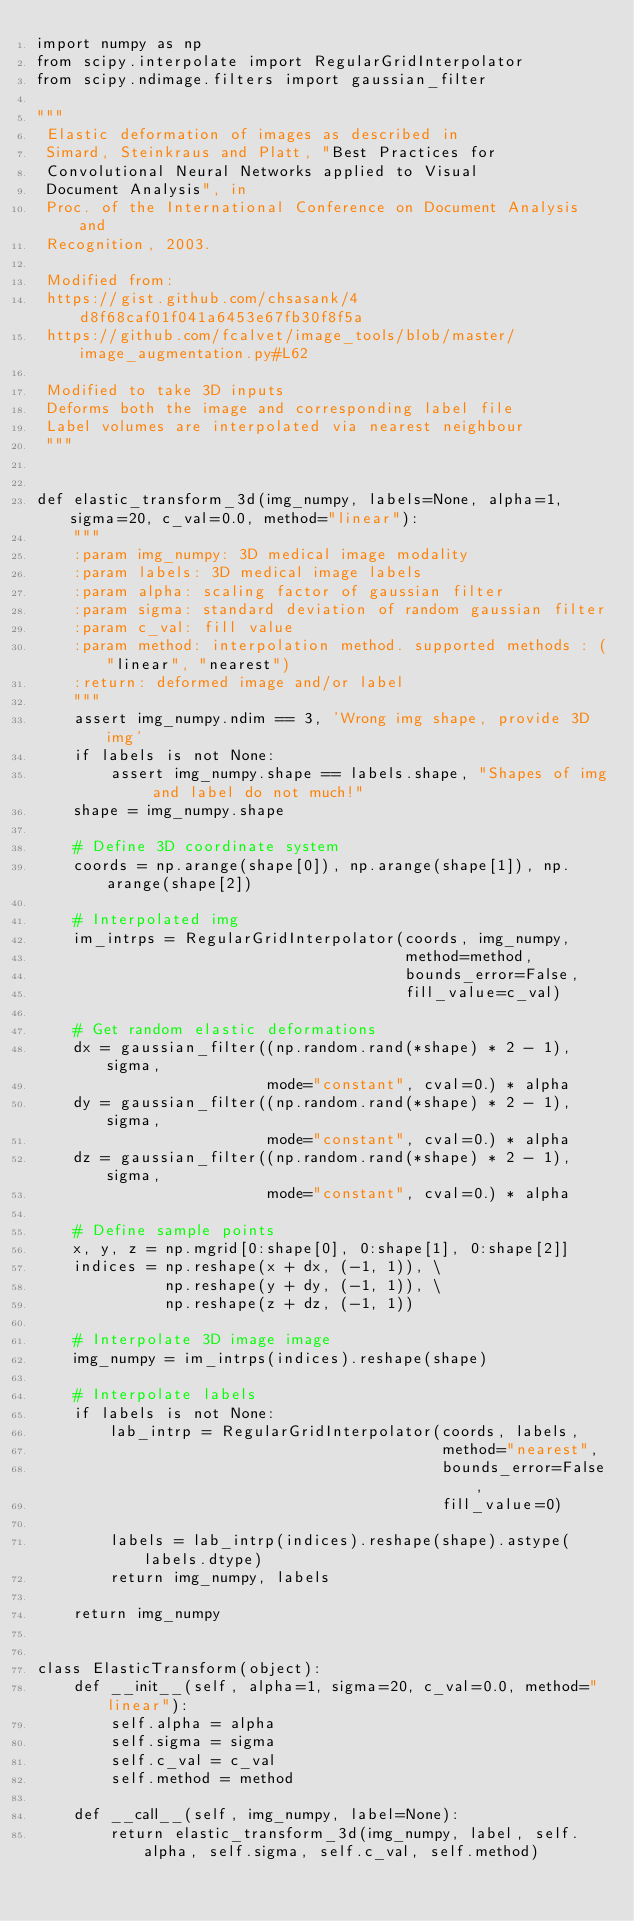Convert code to text. <code><loc_0><loc_0><loc_500><loc_500><_Python_>import numpy as np
from scipy.interpolate import RegularGridInterpolator
from scipy.ndimage.filters import gaussian_filter

"""
 Elastic deformation of images as described in
 Simard, Steinkraus and Platt, "Best Practices for
 Convolutional Neural Networks applied to Visual
 Document Analysis", in
 Proc. of the International Conference on Document Analysis and
 Recognition, 2003.

 Modified from:
 https://gist.github.com/chsasank/4d8f68caf01f041a6453e67fb30f8f5a
 https://github.com/fcalvet/image_tools/blob/master/image_augmentation.py#L62

 Modified to take 3D inputs
 Deforms both the image and corresponding label file
 Label volumes are interpolated via nearest neighbour 
 """


def elastic_transform_3d(img_numpy, labels=None, alpha=1, sigma=20, c_val=0.0, method="linear"):
    """
    :param img_numpy: 3D medical image modality
    :param labels: 3D medical image labels
    :param alpha: scaling factor of gaussian filter
    :param sigma: standard deviation of random gaussian filter
    :param c_val: fill value
    :param method: interpolation method. supported methods : ("linear", "nearest")
    :return: deformed image and/or label
    """
    assert img_numpy.ndim == 3, 'Wrong img shape, provide 3D img'
    if labels is not None:
        assert img_numpy.shape == labels.shape, "Shapes of img and label do not much!"
    shape = img_numpy.shape

    # Define 3D coordinate system
    coords = np.arange(shape[0]), np.arange(shape[1]), np.arange(shape[2])

    # Interpolated img
    im_intrps = RegularGridInterpolator(coords, img_numpy,
                                        method=method,
                                        bounds_error=False,
                                        fill_value=c_val)

    # Get random elastic deformations
    dx = gaussian_filter((np.random.rand(*shape) * 2 - 1), sigma,
                         mode="constant", cval=0.) * alpha
    dy = gaussian_filter((np.random.rand(*shape) * 2 - 1), sigma,
                         mode="constant", cval=0.) * alpha
    dz = gaussian_filter((np.random.rand(*shape) * 2 - 1), sigma,
                         mode="constant", cval=0.) * alpha

    # Define sample points
    x, y, z = np.mgrid[0:shape[0], 0:shape[1], 0:shape[2]]
    indices = np.reshape(x + dx, (-1, 1)), \
              np.reshape(y + dy, (-1, 1)), \
              np.reshape(z + dz, (-1, 1))

    # Interpolate 3D image image
    img_numpy = im_intrps(indices).reshape(shape)

    # Interpolate labels
    if labels is not None:
        lab_intrp = RegularGridInterpolator(coords, labels,
                                            method="nearest",
                                            bounds_error=False,
                                            fill_value=0)

        labels = lab_intrp(indices).reshape(shape).astype(labels.dtype)
        return img_numpy, labels

    return img_numpy


class ElasticTransform(object):
    def __init__(self, alpha=1, sigma=20, c_val=0.0, method="linear"):
        self.alpha = alpha
        self.sigma = sigma
        self.c_val = c_val
        self.method = method

    def __call__(self, img_numpy, label=None):
        return elastic_transform_3d(img_numpy, label, self.alpha, self.sigma, self.c_val, self.method)
</code> 